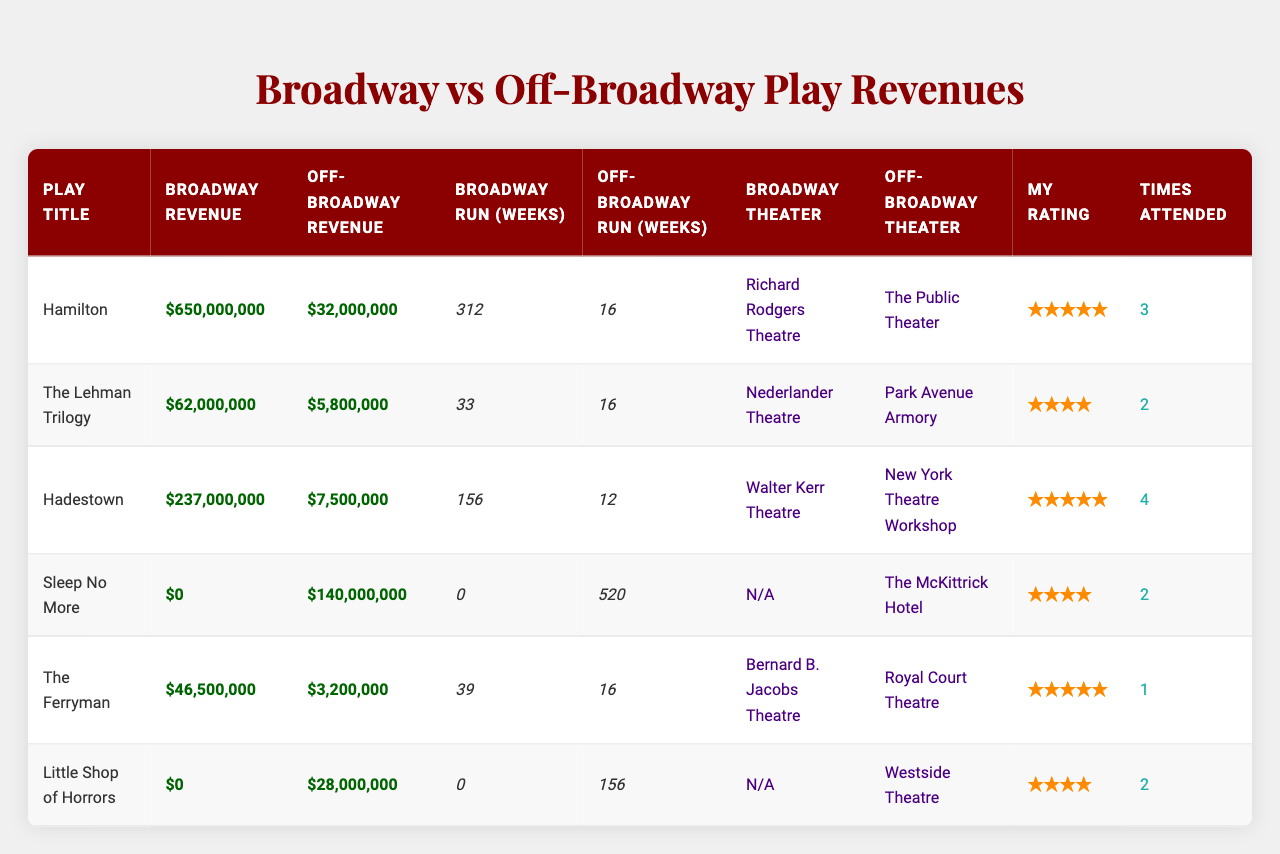What is the highest box office revenue for a Broadway play? Looking at the Broadway revenue column, "Hamilton" has the highest revenue at $650,000,000.
Answer: $650,000,000 Which off-Broadway production has the highest revenue? In the off-Broadway revenue column, "Sleep No More" shows the highest revenue at $140,000,000.
Answer: $140,000,000 How many weeks did "The Ferryman" run on Broadway? The Broadway run weeks for "The Ferryman" is provided in the table as 39 weeks.
Answer: 39 weeks What is the total Broadway revenue for all plays listed? Adding the Broadway revenues: $650,000,000 + $62,000,000 + $237,000,000 + $0 + $46,500,000 + $0 = $995,500,000.
Answer: $995,500,000 How many times have you attended "Hadestown"? The table indicates that I have attended "Hadestown" 4 times.
Answer: 4 times What is the difference in revenue between "Hamilton" on Broadway and "The Lehman Trilogy" off-Broadway? The Broadway revenue for "Hamilton" is $650,000,000 and the off-Broadway revenue for "The Lehman Trilogy" is $5,800,000. The difference is $650,000,000 - $5,800,000 = $644,200,000.
Answer: $644,200,000 Which play had a longer off-Broadway run, "Little Shop of Horrors" or "The Ferryman"? "Little Shop of Horrors" had a run of 156 weeks while "The Ferryman" had 16 weeks. Thus, "Little Shop of Horrors" had the longer run.
Answer: "Little Shop of Horrors" Is there any play that did not generate any revenue on Broadway? Yes, both "Sleep No More" and "Little Shop of Horrors" show $0 revenue for Broadway.
Answer: Yes What is the average off-Broadway revenue across all plays listed? The total off-Broadway revenue is $32,000,000 + $5,800,000 + $7,500,000 + $140,000,000 + $3,200,000 + $28,000,000 = $216,500,000. Dividing by 6 gives an average of $36,083,333.33, rounded to $36,083,333.
Answer: $36,083,333 Which play on Broadway had the most weeks of performance? "Hamilton" ran for the most weeks at 312 on Broadway.
Answer: "Hamilton" 